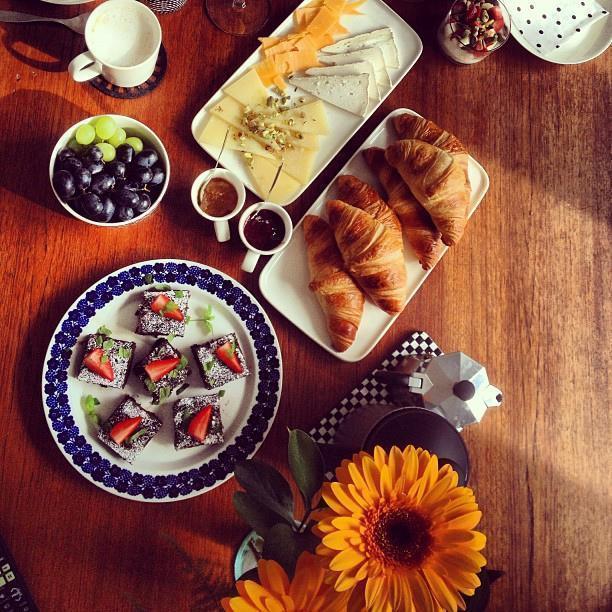Which people group invented the bread seen here?
Pick the right solution, then justify: 'Answer: answer
Rationale: rationale.'
Options: French, belgian, british, austrian. Answer: austrian.
Rationale: French people like croissants. 